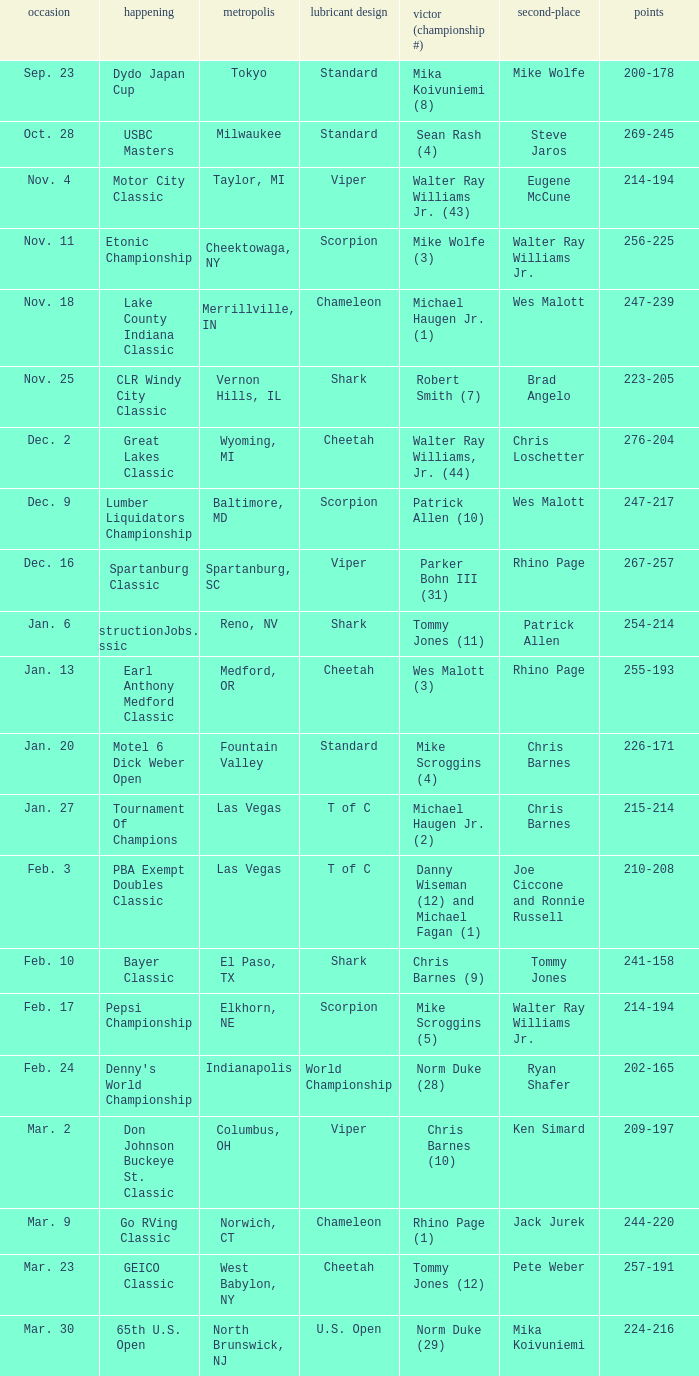Which Oil Pattern has a Winner (Title #) of mike wolfe (3)? Scorpion. 